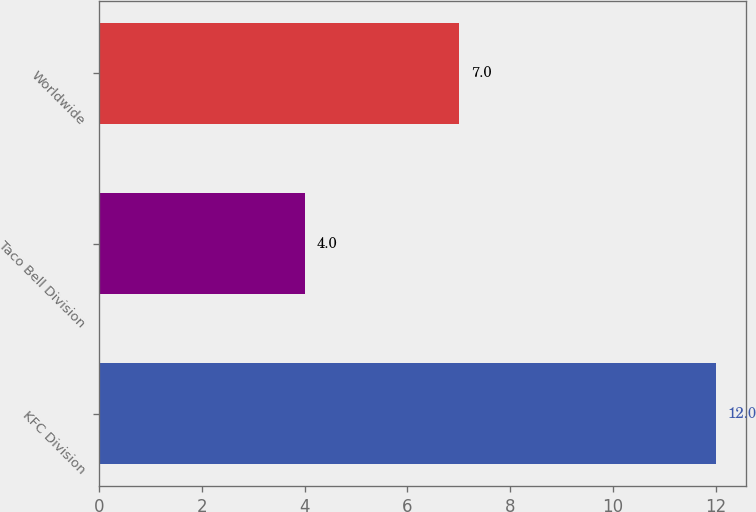<chart> <loc_0><loc_0><loc_500><loc_500><bar_chart><fcel>KFC Division<fcel>Taco Bell Division<fcel>Worldwide<nl><fcel>12<fcel>4<fcel>7<nl></chart> 